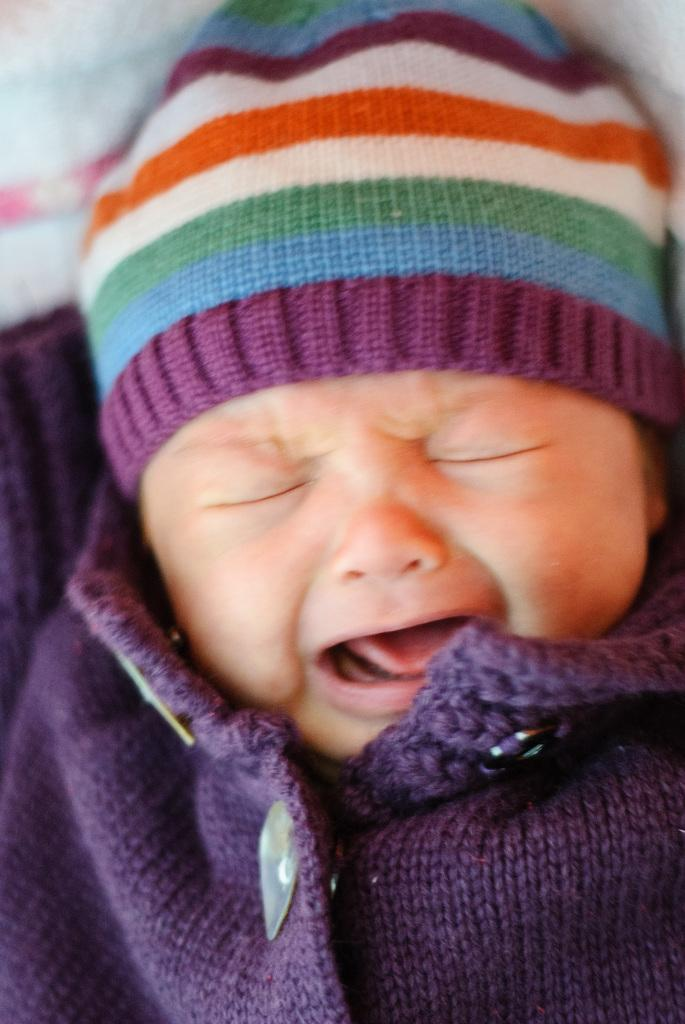What is the main subject of the image? The main subject of the image is a baby. What is the baby doing in the image? The baby is sleeping in the image. Where is the baby located in the image? The baby is on a bed in the image. What type of disgust can be seen on the baby's face in the image? There is no indication of disgust on the baby's face in the image, as the baby is sleeping. Can you tell me how many rabbits are present in the cemetery in the image? There is no cemetery or rabbits present in the image; it features a baby sleeping on a bed. 